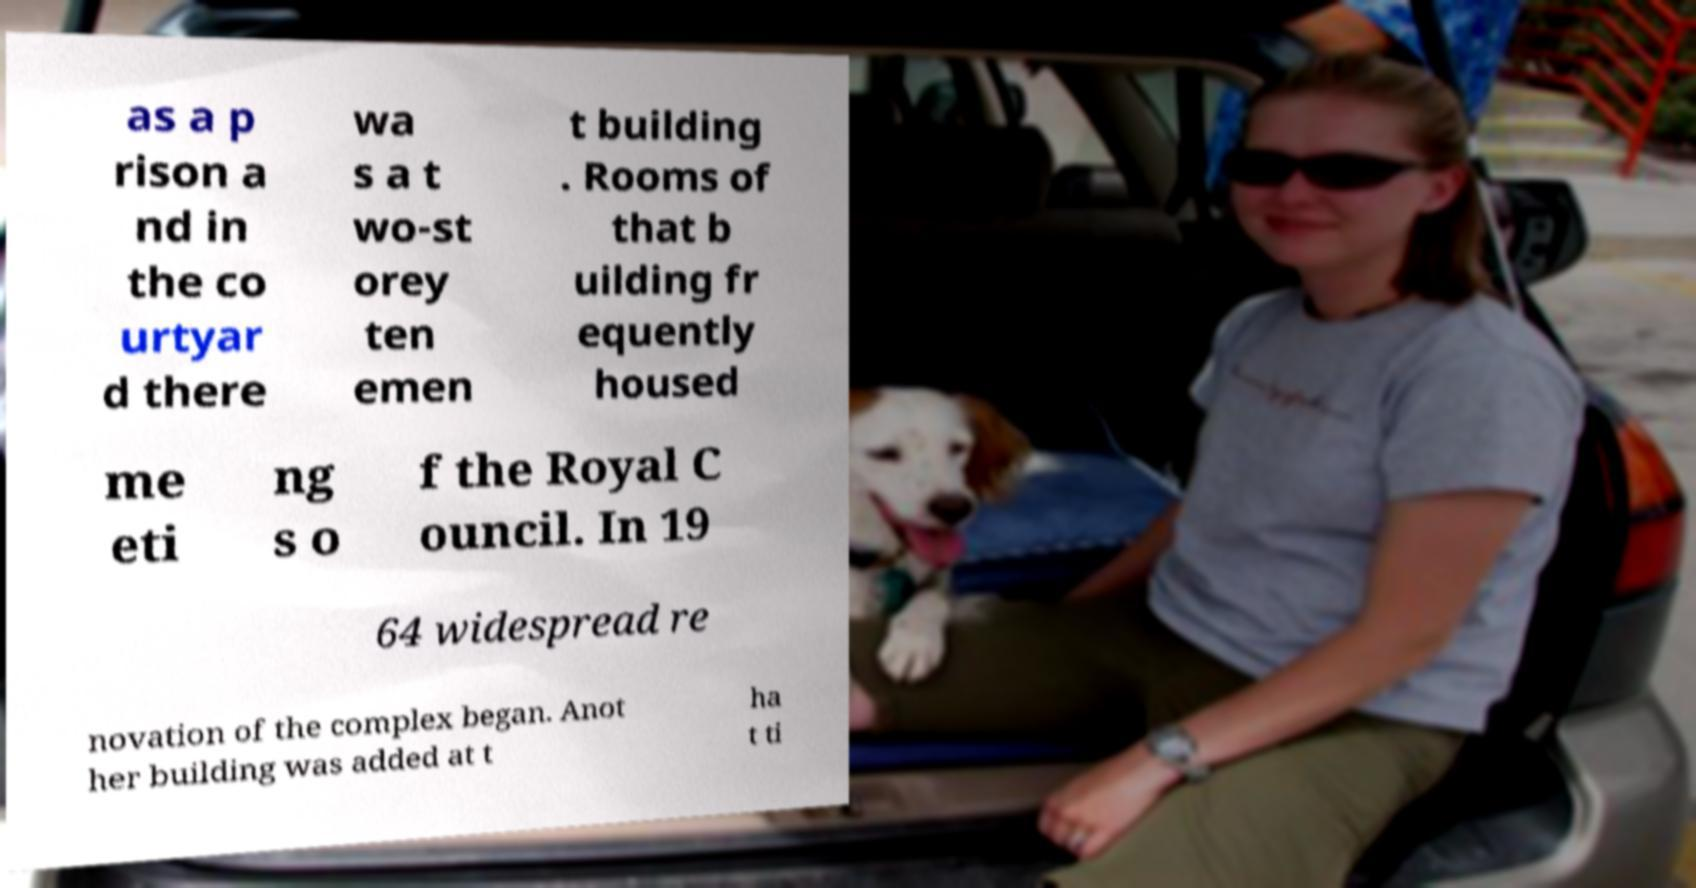There's text embedded in this image that I need extracted. Can you transcribe it verbatim? as a p rison a nd in the co urtyar d there wa s a t wo-st orey ten emen t building . Rooms of that b uilding fr equently housed me eti ng s o f the Royal C ouncil. In 19 64 widespread re novation of the complex began. Anot her building was added at t ha t ti 